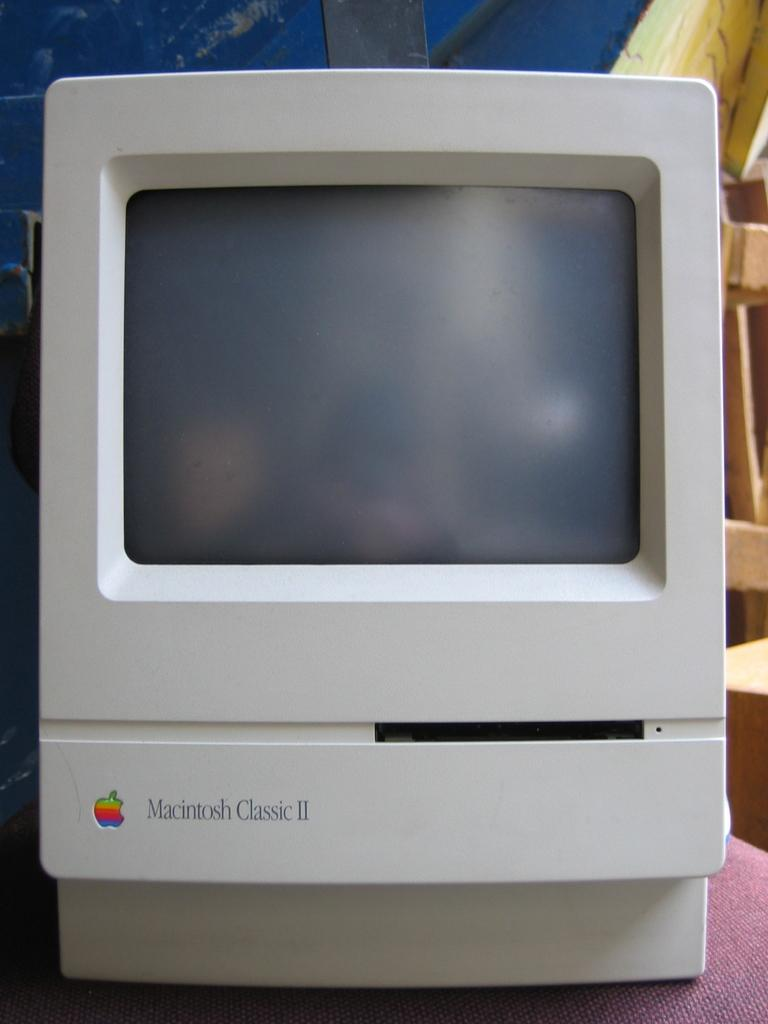<image>
Render a clear and concise summary of the photo. A vintage Macintosh Classic II computer and monitor all in one. 